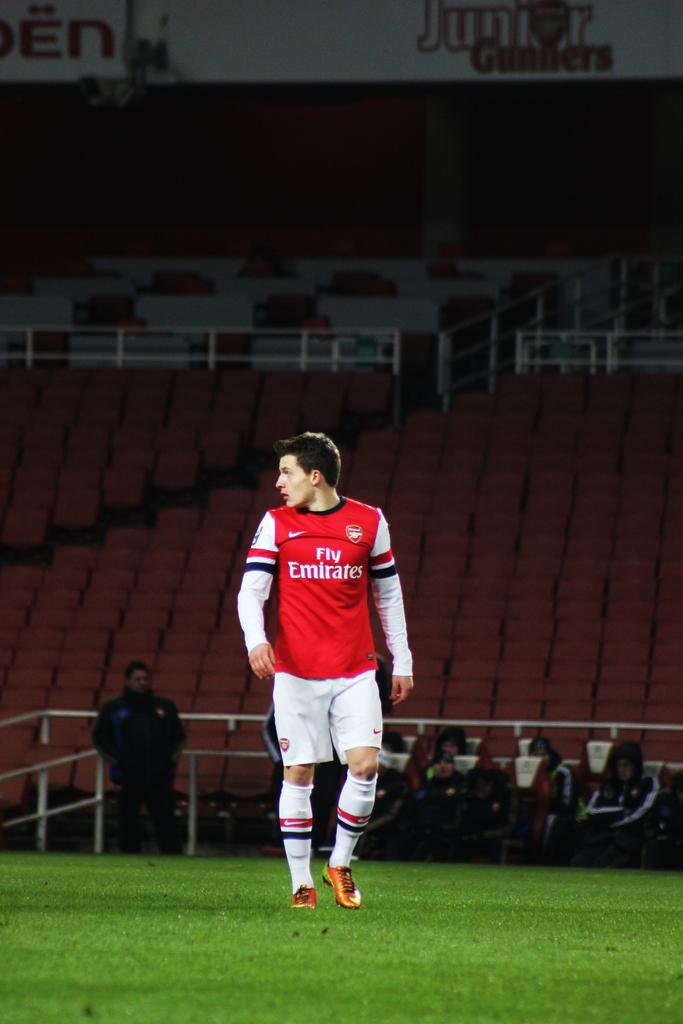<image>
Present a compact description of the photo's key features. man in red and white fly ermirates jersey walking on field in almost empty stadium 